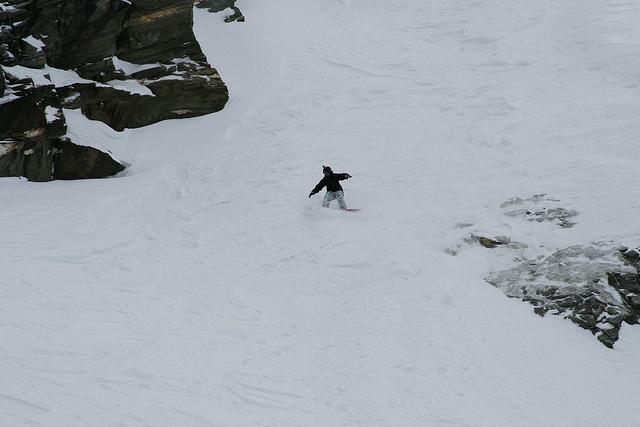Did he lose his ski poles?
Write a very short answer. No. What time of year was this picture taken?
Give a very brief answer. Winter. Has the person fallen?
Quick response, please. No. How many people are visible?
Keep it brief. 1. Is there a beard in the picture?
Keep it brief. No. Is this a well-worn trail?
Be succinct. No. Is the snow covering rocks?
Be succinct. Yes. Is he skiing?
Quick response, please. No. What is behind the person?
Be succinct. Snow. How fast do you suppose this skier is traveling?
Be succinct. Fast. 